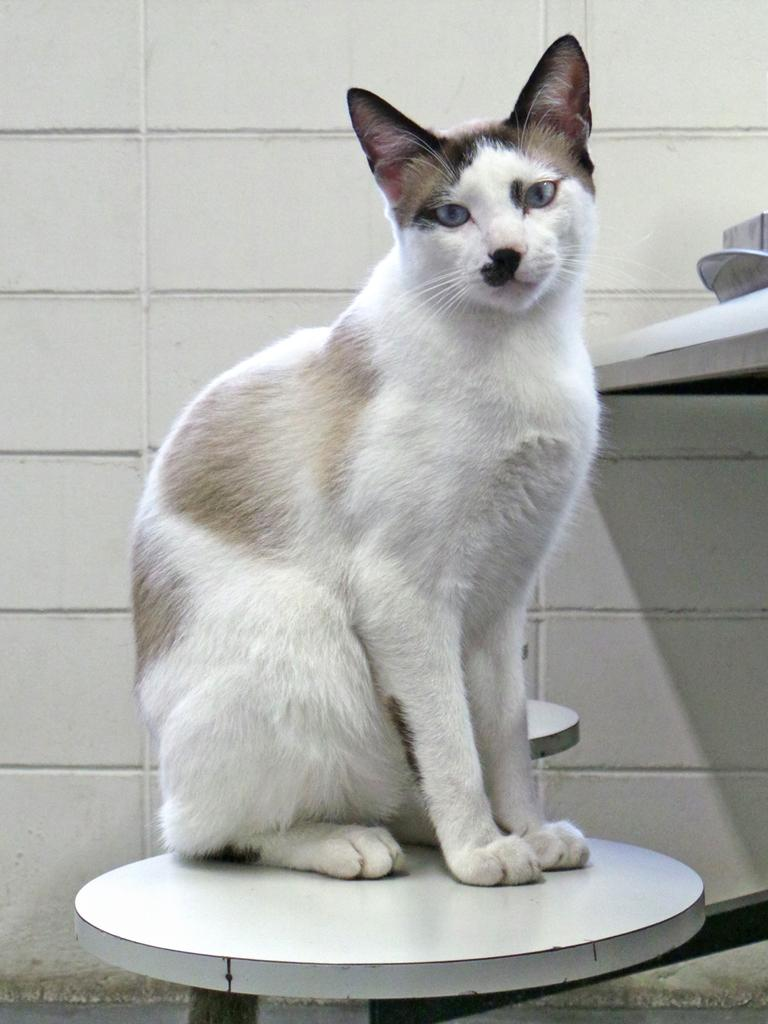What is the main object in the image? There is a white color object attached to a rod in the image. What is sitting on the white object? A: A cat is sitting on the white object. What can be seen in the background of the image? There is a wall in the background. Are there any other white objects in the image? Yes, there is a white object on the right side of the image. What type of statement is the cat making in the image? The image does not depict the cat making any statements, as it is a visual medium and not a platform for verbal communication. --- Facts: 1. There is a person holding a camera in the image. 2. The person is standing on a bridge. 3. There is a river below the bridge. 4. The sky is visible in the image. Absurd Topics: dance, book, bird Conversation: What is the person in the image doing? The person in the image is holding a camera. Where is the person standing in the image? The person is standing on a bridge. What can be seen below the bridge? There is a river below the bridge. What is visible in the background of the image? The sky is visible in the image. Reasoning: Let's think step by step in order to produce the conversation. We start by identifying the main subject in the image, which is the person holding a camera. Then, we describe the person's location, which is on a bridge. Next, we mention the river below the bridge, providing context for the scene. Finally, we point out the presence of the sky in the background, adding more detail to the description. Absurd Question/Answer: What type of dance is the person performing on the bridge in the image? The image does not depict the person performing any dance; they are holding a camera and standing on a bridge. --- Facts: 1. There is a person sitting on a chair in the image. 2. The person is holding a book. 3. There is a table next to the chair. 4. The table has a lamp on it. 5. The background of the image is a room. Absurd Topics: parrot, ocean, bicycle Conversation: What is the person in the image doing? The person in the image is sitting on a chair and holding a book. What is located next to the chair? There is a table next to the chair. What is on the table? The table has a lamp on it. What can be seen in the background of the image? The background of the image is a room. Reasoning: Let's think step by step in order to produce the conversation. We start by identifying 